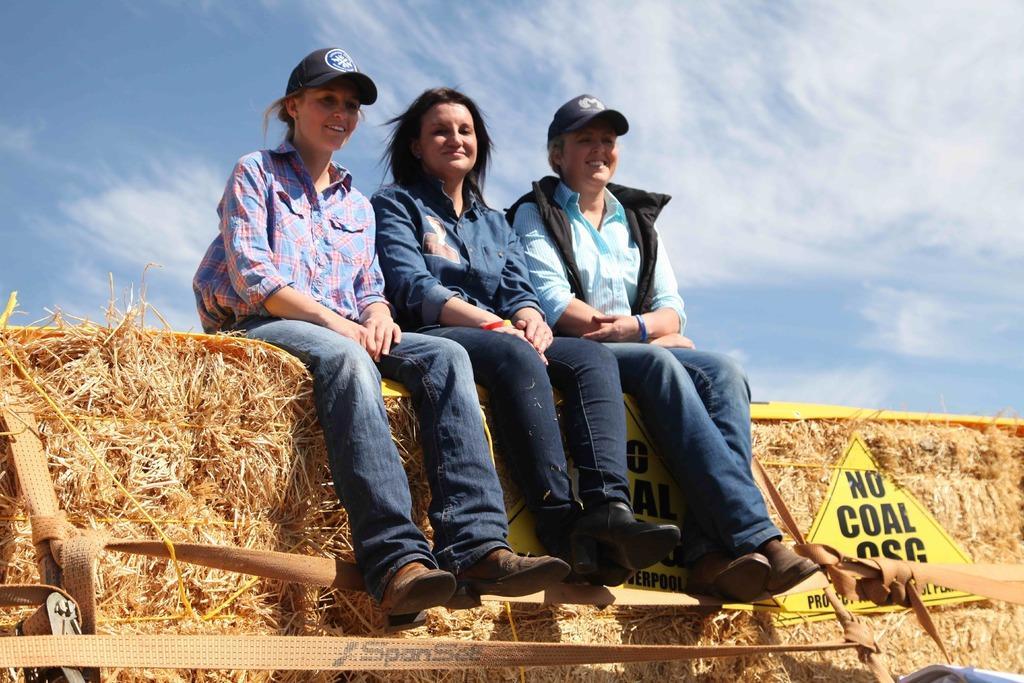Can you describe this image briefly? There are three persons sitting on a grassy wall in the middle of this image , and there is a sky in the background. 